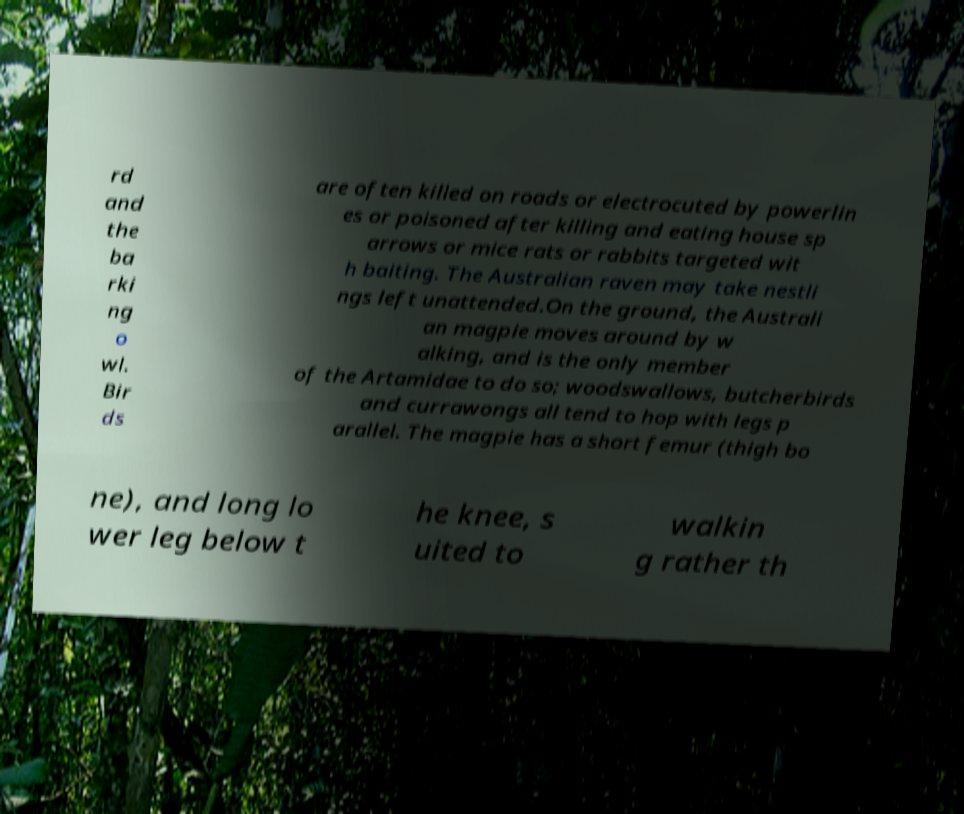Could you extract and type out the text from this image? rd and the ba rki ng o wl. Bir ds are often killed on roads or electrocuted by powerlin es or poisoned after killing and eating house sp arrows or mice rats or rabbits targeted wit h baiting. The Australian raven may take nestli ngs left unattended.On the ground, the Australi an magpie moves around by w alking, and is the only member of the Artamidae to do so; woodswallows, butcherbirds and currawongs all tend to hop with legs p arallel. The magpie has a short femur (thigh bo ne), and long lo wer leg below t he knee, s uited to walkin g rather th 